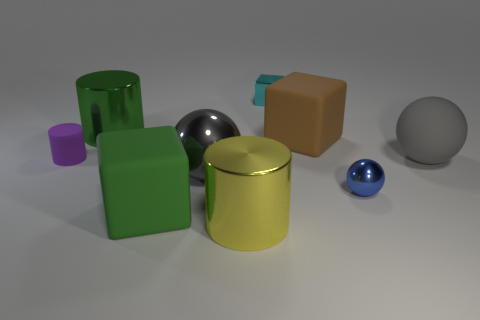The gray sphere that is the same material as the purple thing is what size?
Your answer should be compact. Large. Is the number of small rubber things greater than the number of red cubes?
Make the answer very short. Yes. There is a yellow cylinder that is the same size as the brown cube; what is its material?
Your answer should be compact. Metal. Does the rubber block behind the purple thing have the same size as the cyan shiny block?
Give a very brief answer. No. How many blocks are tiny blue metal things or big metal objects?
Offer a very short reply. 0. There is a block on the left side of the large yellow thing; what material is it?
Your answer should be very brief. Rubber. Are there fewer tiny brown rubber spheres than green things?
Offer a very short reply. Yes. There is a matte thing that is both in front of the tiny cylinder and on the left side of the gray rubber ball; what is its size?
Keep it short and to the point. Large. What is the size of the matte cube that is in front of the big gray object that is on the right side of the big rubber cube that is behind the matte cylinder?
Provide a short and direct response. Large. What number of other things are the same color as the tiny sphere?
Offer a very short reply. 0. 